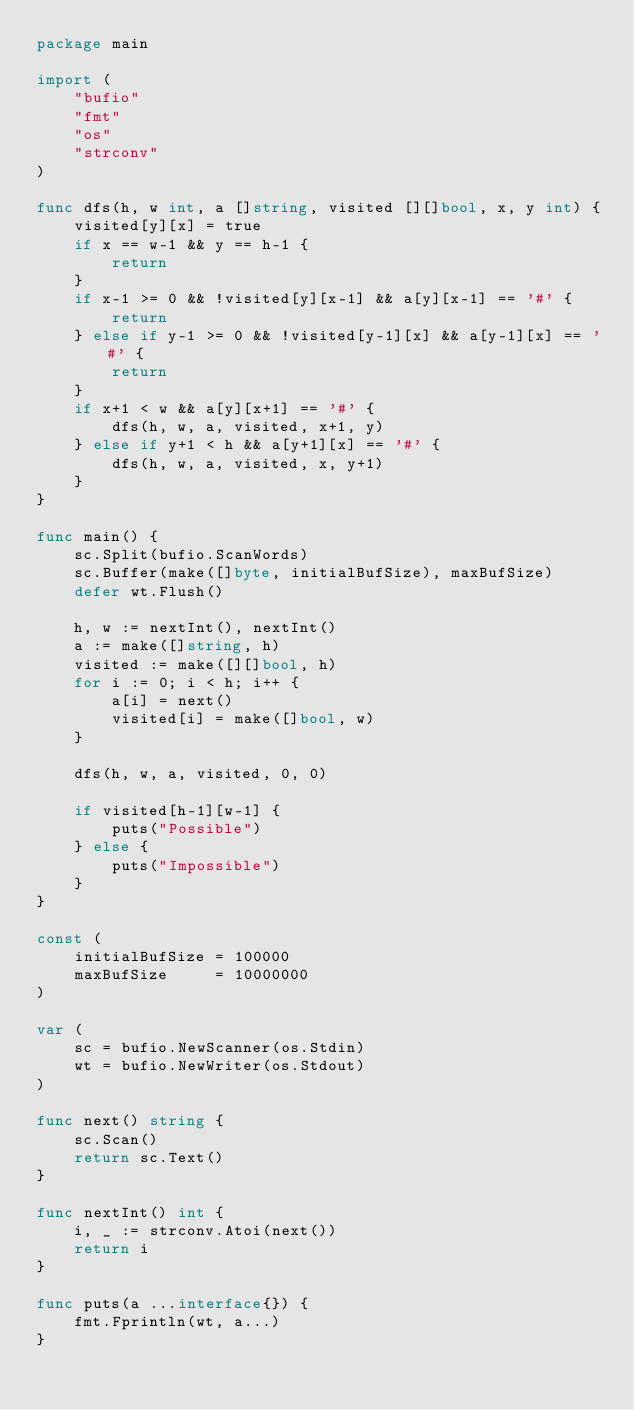Convert code to text. <code><loc_0><loc_0><loc_500><loc_500><_Go_>package main

import (
	"bufio"
	"fmt"
	"os"
	"strconv"
)

func dfs(h, w int, a []string, visited [][]bool, x, y int) {
	visited[y][x] = true
	if x == w-1 && y == h-1 {
		return
	}
	if x-1 >= 0 && !visited[y][x-1] && a[y][x-1] == '#' {
		return
	} else if y-1 >= 0 && !visited[y-1][x] && a[y-1][x] == '#' {
		return
	}
	if x+1 < w && a[y][x+1] == '#' {
		dfs(h, w, a, visited, x+1, y)
	} else if y+1 < h && a[y+1][x] == '#' {
		dfs(h, w, a, visited, x, y+1)
	}
}

func main() {
	sc.Split(bufio.ScanWords)
	sc.Buffer(make([]byte, initialBufSize), maxBufSize)
	defer wt.Flush()

	h, w := nextInt(), nextInt()
	a := make([]string, h)
	visited := make([][]bool, h)
	for i := 0; i < h; i++ {
		a[i] = next()
		visited[i] = make([]bool, w)
	}

	dfs(h, w, a, visited, 0, 0)

	if visited[h-1][w-1] {
		puts("Possible")
	} else {
		puts("Impossible")
	}
}

const (
	initialBufSize = 100000
	maxBufSize     = 10000000
)

var (
	sc = bufio.NewScanner(os.Stdin)
	wt = bufio.NewWriter(os.Stdout)
)

func next() string {
	sc.Scan()
	return sc.Text()
}

func nextInt() int {
	i, _ := strconv.Atoi(next())
	return i
}

func puts(a ...interface{}) {
	fmt.Fprintln(wt, a...)
}
</code> 